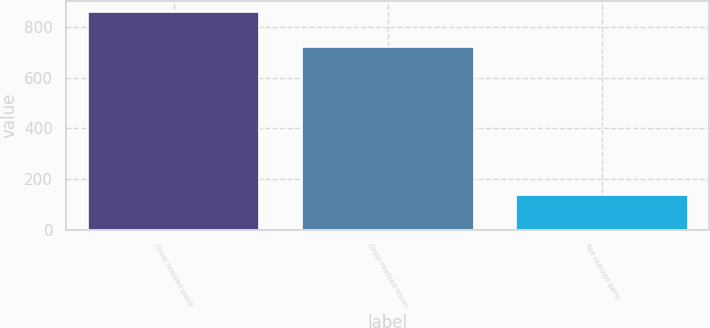Convert chart. <chart><loc_0><loc_0><loc_500><loc_500><bar_chart><fcel>Gross realized gains<fcel>Gross realized losses<fcel>Net realized gains<nl><fcel>861<fcel>723<fcel>138<nl></chart> 